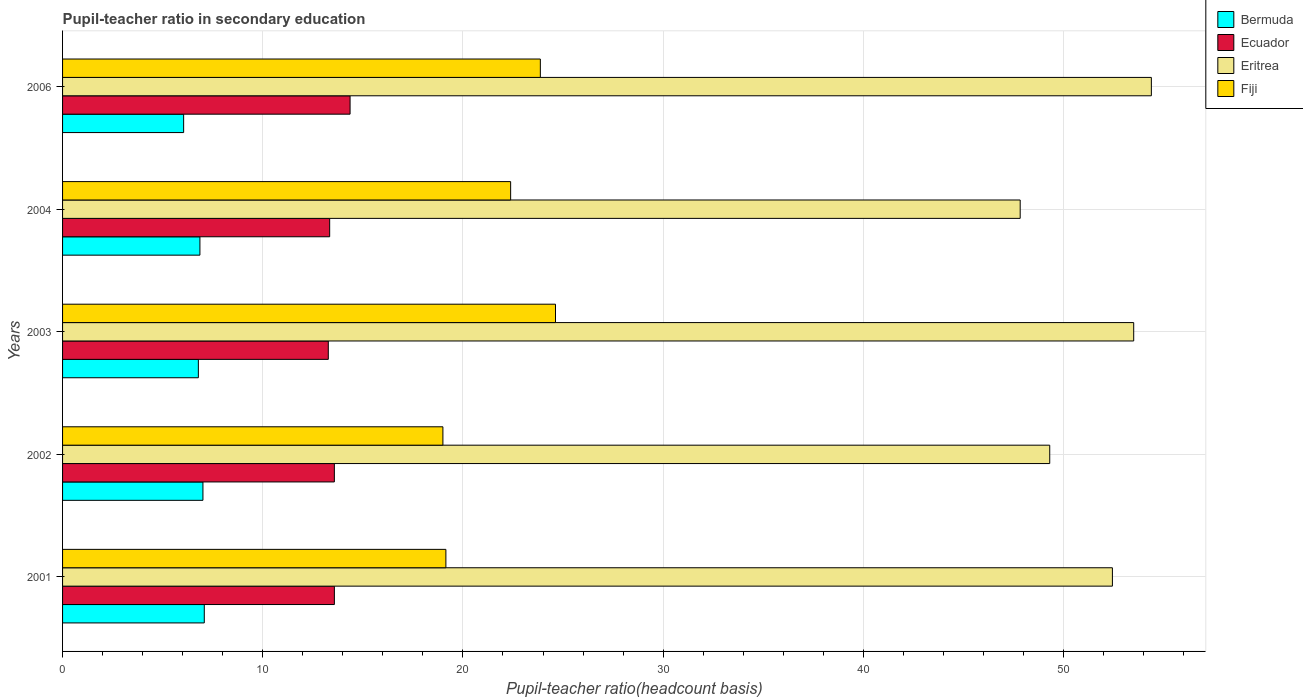How many groups of bars are there?
Your response must be concise. 5. How many bars are there on the 4th tick from the bottom?
Provide a succinct answer. 4. What is the label of the 3rd group of bars from the top?
Provide a succinct answer. 2003. What is the pupil-teacher ratio in secondary education in Ecuador in 2002?
Provide a short and direct response. 13.58. Across all years, what is the maximum pupil-teacher ratio in secondary education in Bermuda?
Provide a succinct answer. 7.08. Across all years, what is the minimum pupil-teacher ratio in secondary education in Fiji?
Give a very brief answer. 19. What is the total pupil-teacher ratio in secondary education in Bermuda in the graph?
Offer a terse response. 33.78. What is the difference between the pupil-teacher ratio in secondary education in Bermuda in 2002 and that in 2006?
Offer a very short reply. 0.96. What is the difference between the pupil-teacher ratio in secondary education in Ecuador in 2001 and the pupil-teacher ratio in secondary education in Bermuda in 2003?
Give a very brief answer. 6.8. What is the average pupil-teacher ratio in secondary education in Ecuador per year?
Make the answer very short. 13.63. In the year 2002, what is the difference between the pupil-teacher ratio in secondary education in Ecuador and pupil-teacher ratio in secondary education in Fiji?
Offer a terse response. -5.42. What is the ratio of the pupil-teacher ratio in secondary education in Ecuador in 2003 to that in 2006?
Give a very brief answer. 0.92. Is the pupil-teacher ratio in secondary education in Bermuda in 2001 less than that in 2003?
Provide a short and direct response. No. What is the difference between the highest and the second highest pupil-teacher ratio in secondary education in Fiji?
Your answer should be very brief. 0.76. What is the difference between the highest and the lowest pupil-teacher ratio in secondary education in Fiji?
Ensure brevity in your answer.  5.62. Is it the case that in every year, the sum of the pupil-teacher ratio in secondary education in Ecuador and pupil-teacher ratio in secondary education in Eritrea is greater than the sum of pupil-teacher ratio in secondary education in Fiji and pupil-teacher ratio in secondary education in Bermuda?
Your response must be concise. Yes. What does the 4th bar from the top in 2003 represents?
Offer a terse response. Bermuda. What does the 3rd bar from the bottom in 2004 represents?
Provide a short and direct response. Eritrea. Is it the case that in every year, the sum of the pupil-teacher ratio in secondary education in Ecuador and pupil-teacher ratio in secondary education in Eritrea is greater than the pupil-teacher ratio in secondary education in Bermuda?
Keep it short and to the point. Yes. Are all the bars in the graph horizontal?
Make the answer very short. Yes. Are the values on the major ticks of X-axis written in scientific E-notation?
Provide a succinct answer. No. Does the graph contain any zero values?
Provide a succinct answer. No. Does the graph contain grids?
Give a very brief answer. Yes. How many legend labels are there?
Give a very brief answer. 4. What is the title of the graph?
Your response must be concise. Pupil-teacher ratio in secondary education. What is the label or title of the X-axis?
Your answer should be compact. Pupil-teacher ratio(headcount basis). What is the Pupil-teacher ratio(headcount basis) in Bermuda in 2001?
Give a very brief answer. 7.08. What is the Pupil-teacher ratio(headcount basis) in Ecuador in 2001?
Give a very brief answer. 13.58. What is the Pupil-teacher ratio(headcount basis) in Eritrea in 2001?
Provide a short and direct response. 52.44. What is the Pupil-teacher ratio(headcount basis) of Fiji in 2001?
Your answer should be compact. 19.15. What is the Pupil-teacher ratio(headcount basis) in Bermuda in 2002?
Ensure brevity in your answer.  7.01. What is the Pupil-teacher ratio(headcount basis) of Ecuador in 2002?
Your response must be concise. 13.58. What is the Pupil-teacher ratio(headcount basis) in Eritrea in 2002?
Provide a succinct answer. 49.31. What is the Pupil-teacher ratio(headcount basis) in Fiji in 2002?
Make the answer very short. 19. What is the Pupil-teacher ratio(headcount basis) in Bermuda in 2003?
Offer a terse response. 6.78. What is the Pupil-teacher ratio(headcount basis) of Ecuador in 2003?
Provide a succinct answer. 13.27. What is the Pupil-teacher ratio(headcount basis) of Eritrea in 2003?
Provide a succinct answer. 53.51. What is the Pupil-teacher ratio(headcount basis) of Fiji in 2003?
Provide a succinct answer. 24.62. What is the Pupil-teacher ratio(headcount basis) of Bermuda in 2004?
Your response must be concise. 6.86. What is the Pupil-teacher ratio(headcount basis) of Ecuador in 2004?
Your response must be concise. 13.34. What is the Pupil-teacher ratio(headcount basis) in Eritrea in 2004?
Your response must be concise. 47.84. What is the Pupil-teacher ratio(headcount basis) of Fiji in 2004?
Your answer should be compact. 22.38. What is the Pupil-teacher ratio(headcount basis) of Bermuda in 2006?
Your answer should be compact. 6.05. What is the Pupil-teacher ratio(headcount basis) in Ecuador in 2006?
Your answer should be compact. 14.36. What is the Pupil-teacher ratio(headcount basis) in Eritrea in 2006?
Ensure brevity in your answer.  54.39. What is the Pupil-teacher ratio(headcount basis) in Fiji in 2006?
Ensure brevity in your answer.  23.87. Across all years, what is the maximum Pupil-teacher ratio(headcount basis) in Bermuda?
Ensure brevity in your answer.  7.08. Across all years, what is the maximum Pupil-teacher ratio(headcount basis) in Ecuador?
Your answer should be compact. 14.36. Across all years, what is the maximum Pupil-teacher ratio(headcount basis) in Eritrea?
Provide a succinct answer. 54.39. Across all years, what is the maximum Pupil-teacher ratio(headcount basis) in Fiji?
Ensure brevity in your answer.  24.62. Across all years, what is the minimum Pupil-teacher ratio(headcount basis) in Bermuda?
Offer a terse response. 6.05. Across all years, what is the minimum Pupil-teacher ratio(headcount basis) of Ecuador?
Give a very brief answer. 13.27. Across all years, what is the minimum Pupil-teacher ratio(headcount basis) in Eritrea?
Provide a succinct answer. 47.84. Across all years, what is the minimum Pupil-teacher ratio(headcount basis) of Fiji?
Keep it short and to the point. 19. What is the total Pupil-teacher ratio(headcount basis) of Bermuda in the graph?
Your response must be concise. 33.78. What is the total Pupil-teacher ratio(headcount basis) of Ecuador in the graph?
Ensure brevity in your answer.  68.14. What is the total Pupil-teacher ratio(headcount basis) in Eritrea in the graph?
Offer a terse response. 257.49. What is the total Pupil-teacher ratio(headcount basis) of Fiji in the graph?
Offer a very short reply. 109.02. What is the difference between the Pupil-teacher ratio(headcount basis) of Bermuda in 2001 and that in 2002?
Ensure brevity in your answer.  0.07. What is the difference between the Pupil-teacher ratio(headcount basis) in Ecuador in 2001 and that in 2002?
Ensure brevity in your answer.  0. What is the difference between the Pupil-teacher ratio(headcount basis) in Eritrea in 2001 and that in 2002?
Your answer should be compact. 3.13. What is the difference between the Pupil-teacher ratio(headcount basis) in Fiji in 2001 and that in 2002?
Give a very brief answer. 0.15. What is the difference between the Pupil-teacher ratio(headcount basis) in Bermuda in 2001 and that in 2003?
Offer a very short reply. 0.3. What is the difference between the Pupil-teacher ratio(headcount basis) in Ecuador in 2001 and that in 2003?
Your answer should be compact. 0.3. What is the difference between the Pupil-teacher ratio(headcount basis) of Eritrea in 2001 and that in 2003?
Make the answer very short. -1.06. What is the difference between the Pupil-teacher ratio(headcount basis) of Fiji in 2001 and that in 2003?
Your answer should be compact. -5.48. What is the difference between the Pupil-teacher ratio(headcount basis) of Bermuda in 2001 and that in 2004?
Keep it short and to the point. 0.22. What is the difference between the Pupil-teacher ratio(headcount basis) in Ecuador in 2001 and that in 2004?
Ensure brevity in your answer.  0.24. What is the difference between the Pupil-teacher ratio(headcount basis) of Eritrea in 2001 and that in 2004?
Offer a very short reply. 4.61. What is the difference between the Pupil-teacher ratio(headcount basis) in Fiji in 2001 and that in 2004?
Keep it short and to the point. -3.23. What is the difference between the Pupil-teacher ratio(headcount basis) of Bermuda in 2001 and that in 2006?
Your response must be concise. 1.03. What is the difference between the Pupil-teacher ratio(headcount basis) of Ecuador in 2001 and that in 2006?
Ensure brevity in your answer.  -0.78. What is the difference between the Pupil-teacher ratio(headcount basis) in Eritrea in 2001 and that in 2006?
Your answer should be compact. -1.95. What is the difference between the Pupil-teacher ratio(headcount basis) in Fiji in 2001 and that in 2006?
Provide a succinct answer. -4.72. What is the difference between the Pupil-teacher ratio(headcount basis) of Bermuda in 2002 and that in 2003?
Offer a terse response. 0.23. What is the difference between the Pupil-teacher ratio(headcount basis) of Ecuador in 2002 and that in 2003?
Offer a terse response. 0.3. What is the difference between the Pupil-teacher ratio(headcount basis) in Eritrea in 2002 and that in 2003?
Your answer should be compact. -4.19. What is the difference between the Pupil-teacher ratio(headcount basis) in Fiji in 2002 and that in 2003?
Your response must be concise. -5.62. What is the difference between the Pupil-teacher ratio(headcount basis) in Bermuda in 2002 and that in 2004?
Give a very brief answer. 0.15. What is the difference between the Pupil-teacher ratio(headcount basis) of Ecuador in 2002 and that in 2004?
Your answer should be compact. 0.23. What is the difference between the Pupil-teacher ratio(headcount basis) of Eritrea in 2002 and that in 2004?
Make the answer very short. 1.48. What is the difference between the Pupil-teacher ratio(headcount basis) in Fiji in 2002 and that in 2004?
Keep it short and to the point. -3.38. What is the difference between the Pupil-teacher ratio(headcount basis) in Bermuda in 2002 and that in 2006?
Offer a terse response. 0.96. What is the difference between the Pupil-teacher ratio(headcount basis) in Ecuador in 2002 and that in 2006?
Offer a terse response. -0.78. What is the difference between the Pupil-teacher ratio(headcount basis) in Eritrea in 2002 and that in 2006?
Provide a succinct answer. -5.08. What is the difference between the Pupil-teacher ratio(headcount basis) of Fiji in 2002 and that in 2006?
Your answer should be compact. -4.87. What is the difference between the Pupil-teacher ratio(headcount basis) of Bermuda in 2003 and that in 2004?
Provide a succinct answer. -0.08. What is the difference between the Pupil-teacher ratio(headcount basis) of Ecuador in 2003 and that in 2004?
Your answer should be compact. -0.07. What is the difference between the Pupil-teacher ratio(headcount basis) in Eritrea in 2003 and that in 2004?
Keep it short and to the point. 5.67. What is the difference between the Pupil-teacher ratio(headcount basis) in Fiji in 2003 and that in 2004?
Provide a short and direct response. 2.24. What is the difference between the Pupil-teacher ratio(headcount basis) in Bermuda in 2003 and that in 2006?
Give a very brief answer. 0.73. What is the difference between the Pupil-teacher ratio(headcount basis) of Ecuador in 2003 and that in 2006?
Your answer should be very brief. -1.09. What is the difference between the Pupil-teacher ratio(headcount basis) of Eritrea in 2003 and that in 2006?
Your response must be concise. -0.88. What is the difference between the Pupil-teacher ratio(headcount basis) of Fiji in 2003 and that in 2006?
Ensure brevity in your answer.  0.76. What is the difference between the Pupil-teacher ratio(headcount basis) in Bermuda in 2004 and that in 2006?
Offer a terse response. 0.81. What is the difference between the Pupil-teacher ratio(headcount basis) in Ecuador in 2004 and that in 2006?
Ensure brevity in your answer.  -1.02. What is the difference between the Pupil-teacher ratio(headcount basis) of Eritrea in 2004 and that in 2006?
Make the answer very short. -6.55. What is the difference between the Pupil-teacher ratio(headcount basis) of Fiji in 2004 and that in 2006?
Provide a short and direct response. -1.48. What is the difference between the Pupil-teacher ratio(headcount basis) in Bermuda in 2001 and the Pupil-teacher ratio(headcount basis) in Ecuador in 2002?
Provide a succinct answer. -6.5. What is the difference between the Pupil-teacher ratio(headcount basis) of Bermuda in 2001 and the Pupil-teacher ratio(headcount basis) of Eritrea in 2002?
Ensure brevity in your answer.  -42.23. What is the difference between the Pupil-teacher ratio(headcount basis) in Bermuda in 2001 and the Pupil-teacher ratio(headcount basis) in Fiji in 2002?
Your answer should be compact. -11.92. What is the difference between the Pupil-teacher ratio(headcount basis) in Ecuador in 2001 and the Pupil-teacher ratio(headcount basis) in Eritrea in 2002?
Offer a terse response. -35.73. What is the difference between the Pupil-teacher ratio(headcount basis) in Ecuador in 2001 and the Pupil-teacher ratio(headcount basis) in Fiji in 2002?
Offer a very short reply. -5.42. What is the difference between the Pupil-teacher ratio(headcount basis) of Eritrea in 2001 and the Pupil-teacher ratio(headcount basis) of Fiji in 2002?
Make the answer very short. 33.44. What is the difference between the Pupil-teacher ratio(headcount basis) of Bermuda in 2001 and the Pupil-teacher ratio(headcount basis) of Ecuador in 2003?
Your answer should be compact. -6.2. What is the difference between the Pupil-teacher ratio(headcount basis) of Bermuda in 2001 and the Pupil-teacher ratio(headcount basis) of Eritrea in 2003?
Your answer should be compact. -46.43. What is the difference between the Pupil-teacher ratio(headcount basis) in Bermuda in 2001 and the Pupil-teacher ratio(headcount basis) in Fiji in 2003?
Offer a very short reply. -17.54. What is the difference between the Pupil-teacher ratio(headcount basis) of Ecuador in 2001 and the Pupil-teacher ratio(headcount basis) of Eritrea in 2003?
Offer a very short reply. -39.93. What is the difference between the Pupil-teacher ratio(headcount basis) in Ecuador in 2001 and the Pupil-teacher ratio(headcount basis) in Fiji in 2003?
Provide a succinct answer. -11.05. What is the difference between the Pupil-teacher ratio(headcount basis) in Eritrea in 2001 and the Pupil-teacher ratio(headcount basis) in Fiji in 2003?
Make the answer very short. 27.82. What is the difference between the Pupil-teacher ratio(headcount basis) of Bermuda in 2001 and the Pupil-teacher ratio(headcount basis) of Ecuador in 2004?
Offer a terse response. -6.26. What is the difference between the Pupil-teacher ratio(headcount basis) in Bermuda in 2001 and the Pupil-teacher ratio(headcount basis) in Eritrea in 2004?
Your answer should be compact. -40.76. What is the difference between the Pupil-teacher ratio(headcount basis) in Bermuda in 2001 and the Pupil-teacher ratio(headcount basis) in Fiji in 2004?
Keep it short and to the point. -15.3. What is the difference between the Pupil-teacher ratio(headcount basis) of Ecuador in 2001 and the Pupil-teacher ratio(headcount basis) of Eritrea in 2004?
Give a very brief answer. -34.26. What is the difference between the Pupil-teacher ratio(headcount basis) of Ecuador in 2001 and the Pupil-teacher ratio(headcount basis) of Fiji in 2004?
Offer a terse response. -8.8. What is the difference between the Pupil-teacher ratio(headcount basis) in Eritrea in 2001 and the Pupil-teacher ratio(headcount basis) in Fiji in 2004?
Your response must be concise. 30.06. What is the difference between the Pupil-teacher ratio(headcount basis) of Bermuda in 2001 and the Pupil-teacher ratio(headcount basis) of Ecuador in 2006?
Your answer should be compact. -7.28. What is the difference between the Pupil-teacher ratio(headcount basis) in Bermuda in 2001 and the Pupil-teacher ratio(headcount basis) in Eritrea in 2006?
Your response must be concise. -47.31. What is the difference between the Pupil-teacher ratio(headcount basis) in Bermuda in 2001 and the Pupil-teacher ratio(headcount basis) in Fiji in 2006?
Make the answer very short. -16.79. What is the difference between the Pupil-teacher ratio(headcount basis) of Ecuador in 2001 and the Pupil-teacher ratio(headcount basis) of Eritrea in 2006?
Provide a short and direct response. -40.81. What is the difference between the Pupil-teacher ratio(headcount basis) of Ecuador in 2001 and the Pupil-teacher ratio(headcount basis) of Fiji in 2006?
Offer a terse response. -10.29. What is the difference between the Pupil-teacher ratio(headcount basis) in Eritrea in 2001 and the Pupil-teacher ratio(headcount basis) in Fiji in 2006?
Keep it short and to the point. 28.58. What is the difference between the Pupil-teacher ratio(headcount basis) in Bermuda in 2002 and the Pupil-teacher ratio(headcount basis) in Ecuador in 2003?
Offer a very short reply. -6.26. What is the difference between the Pupil-teacher ratio(headcount basis) of Bermuda in 2002 and the Pupil-teacher ratio(headcount basis) of Eritrea in 2003?
Your answer should be compact. -46.5. What is the difference between the Pupil-teacher ratio(headcount basis) of Bermuda in 2002 and the Pupil-teacher ratio(headcount basis) of Fiji in 2003?
Your response must be concise. -17.61. What is the difference between the Pupil-teacher ratio(headcount basis) of Ecuador in 2002 and the Pupil-teacher ratio(headcount basis) of Eritrea in 2003?
Provide a short and direct response. -39.93. What is the difference between the Pupil-teacher ratio(headcount basis) in Ecuador in 2002 and the Pupil-teacher ratio(headcount basis) in Fiji in 2003?
Provide a short and direct response. -11.05. What is the difference between the Pupil-teacher ratio(headcount basis) in Eritrea in 2002 and the Pupil-teacher ratio(headcount basis) in Fiji in 2003?
Your response must be concise. 24.69. What is the difference between the Pupil-teacher ratio(headcount basis) in Bermuda in 2002 and the Pupil-teacher ratio(headcount basis) in Ecuador in 2004?
Give a very brief answer. -6.33. What is the difference between the Pupil-teacher ratio(headcount basis) in Bermuda in 2002 and the Pupil-teacher ratio(headcount basis) in Eritrea in 2004?
Offer a terse response. -40.83. What is the difference between the Pupil-teacher ratio(headcount basis) of Bermuda in 2002 and the Pupil-teacher ratio(headcount basis) of Fiji in 2004?
Provide a succinct answer. -15.37. What is the difference between the Pupil-teacher ratio(headcount basis) of Ecuador in 2002 and the Pupil-teacher ratio(headcount basis) of Eritrea in 2004?
Provide a succinct answer. -34.26. What is the difference between the Pupil-teacher ratio(headcount basis) of Ecuador in 2002 and the Pupil-teacher ratio(headcount basis) of Fiji in 2004?
Provide a short and direct response. -8.81. What is the difference between the Pupil-teacher ratio(headcount basis) of Eritrea in 2002 and the Pupil-teacher ratio(headcount basis) of Fiji in 2004?
Give a very brief answer. 26.93. What is the difference between the Pupil-teacher ratio(headcount basis) of Bermuda in 2002 and the Pupil-teacher ratio(headcount basis) of Ecuador in 2006?
Ensure brevity in your answer.  -7.35. What is the difference between the Pupil-teacher ratio(headcount basis) of Bermuda in 2002 and the Pupil-teacher ratio(headcount basis) of Eritrea in 2006?
Keep it short and to the point. -47.38. What is the difference between the Pupil-teacher ratio(headcount basis) in Bermuda in 2002 and the Pupil-teacher ratio(headcount basis) in Fiji in 2006?
Ensure brevity in your answer.  -16.86. What is the difference between the Pupil-teacher ratio(headcount basis) in Ecuador in 2002 and the Pupil-teacher ratio(headcount basis) in Eritrea in 2006?
Your response must be concise. -40.81. What is the difference between the Pupil-teacher ratio(headcount basis) of Ecuador in 2002 and the Pupil-teacher ratio(headcount basis) of Fiji in 2006?
Make the answer very short. -10.29. What is the difference between the Pupil-teacher ratio(headcount basis) in Eritrea in 2002 and the Pupil-teacher ratio(headcount basis) in Fiji in 2006?
Keep it short and to the point. 25.45. What is the difference between the Pupil-teacher ratio(headcount basis) in Bermuda in 2003 and the Pupil-teacher ratio(headcount basis) in Ecuador in 2004?
Ensure brevity in your answer.  -6.56. What is the difference between the Pupil-teacher ratio(headcount basis) of Bermuda in 2003 and the Pupil-teacher ratio(headcount basis) of Eritrea in 2004?
Ensure brevity in your answer.  -41.05. What is the difference between the Pupil-teacher ratio(headcount basis) in Bermuda in 2003 and the Pupil-teacher ratio(headcount basis) in Fiji in 2004?
Give a very brief answer. -15.6. What is the difference between the Pupil-teacher ratio(headcount basis) in Ecuador in 2003 and the Pupil-teacher ratio(headcount basis) in Eritrea in 2004?
Your answer should be very brief. -34.56. What is the difference between the Pupil-teacher ratio(headcount basis) of Ecuador in 2003 and the Pupil-teacher ratio(headcount basis) of Fiji in 2004?
Your answer should be compact. -9.11. What is the difference between the Pupil-teacher ratio(headcount basis) in Eritrea in 2003 and the Pupil-teacher ratio(headcount basis) in Fiji in 2004?
Offer a terse response. 31.12. What is the difference between the Pupil-teacher ratio(headcount basis) of Bermuda in 2003 and the Pupil-teacher ratio(headcount basis) of Ecuador in 2006?
Keep it short and to the point. -7.58. What is the difference between the Pupil-teacher ratio(headcount basis) of Bermuda in 2003 and the Pupil-teacher ratio(headcount basis) of Eritrea in 2006?
Your answer should be compact. -47.61. What is the difference between the Pupil-teacher ratio(headcount basis) in Bermuda in 2003 and the Pupil-teacher ratio(headcount basis) in Fiji in 2006?
Your response must be concise. -17.08. What is the difference between the Pupil-teacher ratio(headcount basis) of Ecuador in 2003 and the Pupil-teacher ratio(headcount basis) of Eritrea in 2006?
Provide a short and direct response. -41.12. What is the difference between the Pupil-teacher ratio(headcount basis) of Ecuador in 2003 and the Pupil-teacher ratio(headcount basis) of Fiji in 2006?
Make the answer very short. -10.59. What is the difference between the Pupil-teacher ratio(headcount basis) in Eritrea in 2003 and the Pupil-teacher ratio(headcount basis) in Fiji in 2006?
Ensure brevity in your answer.  29.64. What is the difference between the Pupil-teacher ratio(headcount basis) in Bermuda in 2004 and the Pupil-teacher ratio(headcount basis) in Ecuador in 2006?
Your response must be concise. -7.5. What is the difference between the Pupil-teacher ratio(headcount basis) of Bermuda in 2004 and the Pupil-teacher ratio(headcount basis) of Eritrea in 2006?
Give a very brief answer. -47.53. What is the difference between the Pupil-teacher ratio(headcount basis) of Bermuda in 2004 and the Pupil-teacher ratio(headcount basis) of Fiji in 2006?
Your response must be concise. -17.01. What is the difference between the Pupil-teacher ratio(headcount basis) in Ecuador in 2004 and the Pupil-teacher ratio(headcount basis) in Eritrea in 2006?
Make the answer very short. -41.05. What is the difference between the Pupil-teacher ratio(headcount basis) in Ecuador in 2004 and the Pupil-teacher ratio(headcount basis) in Fiji in 2006?
Give a very brief answer. -10.52. What is the difference between the Pupil-teacher ratio(headcount basis) of Eritrea in 2004 and the Pupil-teacher ratio(headcount basis) of Fiji in 2006?
Your answer should be very brief. 23.97. What is the average Pupil-teacher ratio(headcount basis) of Bermuda per year?
Your answer should be compact. 6.76. What is the average Pupil-teacher ratio(headcount basis) in Ecuador per year?
Your answer should be compact. 13.63. What is the average Pupil-teacher ratio(headcount basis) in Eritrea per year?
Offer a very short reply. 51.5. What is the average Pupil-teacher ratio(headcount basis) of Fiji per year?
Offer a terse response. 21.8. In the year 2001, what is the difference between the Pupil-teacher ratio(headcount basis) in Bermuda and Pupil-teacher ratio(headcount basis) in Ecuador?
Provide a short and direct response. -6.5. In the year 2001, what is the difference between the Pupil-teacher ratio(headcount basis) of Bermuda and Pupil-teacher ratio(headcount basis) of Eritrea?
Ensure brevity in your answer.  -45.37. In the year 2001, what is the difference between the Pupil-teacher ratio(headcount basis) of Bermuda and Pupil-teacher ratio(headcount basis) of Fiji?
Make the answer very short. -12.07. In the year 2001, what is the difference between the Pupil-teacher ratio(headcount basis) in Ecuador and Pupil-teacher ratio(headcount basis) in Eritrea?
Make the answer very short. -38.87. In the year 2001, what is the difference between the Pupil-teacher ratio(headcount basis) in Ecuador and Pupil-teacher ratio(headcount basis) in Fiji?
Your answer should be compact. -5.57. In the year 2001, what is the difference between the Pupil-teacher ratio(headcount basis) of Eritrea and Pupil-teacher ratio(headcount basis) of Fiji?
Provide a short and direct response. 33.3. In the year 2002, what is the difference between the Pupil-teacher ratio(headcount basis) in Bermuda and Pupil-teacher ratio(headcount basis) in Ecuador?
Offer a terse response. -6.57. In the year 2002, what is the difference between the Pupil-teacher ratio(headcount basis) in Bermuda and Pupil-teacher ratio(headcount basis) in Eritrea?
Offer a terse response. -42.3. In the year 2002, what is the difference between the Pupil-teacher ratio(headcount basis) of Bermuda and Pupil-teacher ratio(headcount basis) of Fiji?
Make the answer very short. -11.99. In the year 2002, what is the difference between the Pupil-teacher ratio(headcount basis) of Ecuador and Pupil-teacher ratio(headcount basis) of Eritrea?
Your answer should be very brief. -35.74. In the year 2002, what is the difference between the Pupil-teacher ratio(headcount basis) of Ecuador and Pupil-teacher ratio(headcount basis) of Fiji?
Offer a terse response. -5.42. In the year 2002, what is the difference between the Pupil-teacher ratio(headcount basis) of Eritrea and Pupil-teacher ratio(headcount basis) of Fiji?
Your answer should be very brief. 30.31. In the year 2003, what is the difference between the Pupil-teacher ratio(headcount basis) in Bermuda and Pupil-teacher ratio(headcount basis) in Ecuador?
Keep it short and to the point. -6.49. In the year 2003, what is the difference between the Pupil-teacher ratio(headcount basis) in Bermuda and Pupil-teacher ratio(headcount basis) in Eritrea?
Keep it short and to the point. -46.72. In the year 2003, what is the difference between the Pupil-teacher ratio(headcount basis) in Bermuda and Pupil-teacher ratio(headcount basis) in Fiji?
Your answer should be very brief. -17.84. In the year 2003, what is the difference between the Pupil-teacher ratio(headcount basis) of Ecuador and Pupil-teacher ratio(headcount basis) of Eritrea?
Your response must be concise. -40.23. In the year 2003, what is the difference between the Pupil-teacher ratio(headcount basis) of Ecuador and Pupil-teacher ratio(headcount basis) of Fiji?
Your answer should be compact. -11.35. In the year 2003, what is the difference between the Pupil-teacher ratio(headcount basis) of Eritrea and Pupil-teacher ratio(headcount basis) of Fiji?
Your response must be concise. 28.88. In the year 2004, what is the difference between the Pupil-teacher ratio(headcount basis) in Bermuda and Pupil-teacher ratio(headcount basis) in Ecuador?
Offer a terse response. -6.48. In the year 2004, what is the difference between the Pupil-teacher ratio(headcount basis) of Bermuda and Pupil-teacher ratio(headcount basis) of Eritrea?
Offer a terse response. -40.98. In the year 2004, what is the difference between the Pupil-teacher ratio(headcount basis) of Bermuda and Pupil-teacher ratio(headcount basis) of Fiji?
Make the answer very short. -15.52. In the year 2004, what is the difference between the Pupil-teacher ratio(headcount basis) in Ecuador and Pupil-teacher ratio(headcount basis) in Eritrea?
Keep it short and to the point. -34.49. In the year 2004, what is the difference between the Pupil-teacher ratio(headcount basis) in Ecuador and Pupil-teacher ratio(headcount basis) in Fiji?
Offer a terse response. -9.04. In the year 2004, what is the difference between the Pupil-teacher ratio(headcount basis) of Eritrea and Pupil-teacher ratio(headcount basis) of Fiji?
Make the answer very short. 25.45. In the year 2006, what is the difference between the Pupil-teacher ratio(headcount basis) of Bermuda and Pupil-teacher ratio(headcount basis) of Ecuador?
Give a very brief answer. -8.31. In the year 2006, what is the difference between the Pupil-teacher ratio(headcount basis) of Bermuda and Pupil-teacher ratio(headcount basis) of Eritrea?
Offer a very short reply. -48.34. In the year 2006, what is the difference between the Pupil-teacher ratio(headcount basis) of Bermuda and Pupil-teacher ratio(headcount basis) of Fiji?
Offer a very short reply. -17.82. In the year 2006, what is the difference between the Pupil-teacher ratio(headcount basis) of Ecuador and Pupil-teacher ratio(headcount basis) of Eritrea?
Make the answer very short. -40.03. In the year 2006, what is the difference between the Pupil-teacher ratio(headcount basis) of Ecuador and Pupil-teacher ratio(headcount basis) of Fiji?
Your answer should be compact. -9.51. In the year 2006, what is the difference between the Pupil-teacher ratio(headcount basis) in Eritrea and Pupil-teacher ratio(headcount basis) in Fiji?
Provide a short and direct response. 30.52. What is the ratio of the Pupil-teacher ratio(headcount basis) of Bermuda in 2001 to that in 2002?
Give a very brief answer. 1.01. What is the ratio of the Pupil-teacher ratio(headcount basis) of Ecuador in 2001 to that in 2002?
Keep it short and to the point. 1. What is the ratio of the Pupil-teacher ratio(headcount basis) of Eritrea in 2001 to that in 2002?
Provide a short and direct response. 1.06. What is the ratio of the Pupil-teacher ratio(headcount basis) of Bermuda in 2001 to that in 2003?
Your response must be concise. 1.04. What is the ratio of the Pupil-teacher ratio(headcount basis) of Ecuador in 2001 to that in 2003?
Offer a very short reply. 1.02. What is the ratio of the Pupil-teacher ratio(headcount basis) of Eritrea in 2001 to that in 2003?
Your response must be concise. 0.98. What is the ratio of the Pupil-teacher ratio(headcount basis) in Fiji in 2001 to that in 2003?
Provide a short and direct response. 0.78. What is the ratio of the Pupil-teacher ratio(headcount basis) of Bermuda in 2001 to that in 2004?
Keep it short and to the point. 1.03. What is the ratio of the Pupil-teacher ratio(headcount basis) in Ecuador in 2001 to that in 2004?
Keep it short and to the point. 1.02. What is the ratio of the Pupil-teacher ratio(headcount basis) in Eritrea in 2001 to that in 2004?
Keep it short and to the point. 1.1. What is the ratio of the Pupil-teacher ratio(headcount basis) of Fiji in 2001 to that in 2004?
Keep it short and to the point. 0.86. What is the ratio of the Pupil-teacher ratio(headcount basis) in Bermuda in 2001 to that in 2006?
Your answer should be compact. 1.17. What is the ratio of the Pupil-teacher ratio(headcount basis) in Ecuador in 2001 to that in 2006?
Provide a short and direct response. 0.95. What is the ratio of the Pupil-teacher ratio(headcount basis) of Eritrea in 2001 to that in 2006?
Provide a succinct answer. 0.96. What is the ratio of the Pupil-teacher ratio(headcount basis) in Fiji in 2001 to that in 2006?
Give a very brief answer. 0.8. What is the ratio of the Pupil-teacher ratio(headcount basis) of Bermuda in 2002 to that in 2003?
Offer a terse response. 1.03. What is the ratio of the Pupil-teacher ratio(headcount basis) in Ecuador in 2002 to that in 2003?
Ensure brevity in your answer.  1.02. What is the ratio of the Pupil-teacher ratio(headcount basis) in Eritrea in 2002 to that in 2003?
Offer a very short reply. 0.92. What is the ratio of the Pupil-teacher ratio(headcount basis) in Fiji in 2002 to that in 2003?
Ensure brevity in your answer.  0.77. What is the ratio of the Pupil-teacher ratio(headcount basis) in Bermuda in 2002 to that in 2004?
Make the answer very short. 1.02. What is the ratio of the Pupil-teacher ratio(headcount basis) of Ecuador in 2002 to that in 2004?
Your answer should be compact. 1.02. What is the ratio of the Pupil-teacher ratio(headcount basis) of Eritrea in 2002 to that in 2004?
Ensure brevity in your answer.  1.03. What is the ratio of the Pupil-teacher ratio(headcount basis) in Fiji in 2002 to that in 2004?
Provide a short and direct response. 0.85. What is the ratio of the Pupil-teacher ratio(headcount basis) in Bermuda in 2002 to that in 2006?
Your answer should be compact. 1.16. What is the ratio of the Pupil-teacher ratio(headcount basis) of Ecuador in 2002 to that in 2006?
Provide a short and direct response. 0.95. What is the ratio of the Pupil-teacher ratio(headcount basis) in Eritrea in 2002 to that in 2006?
Provide a short and direct response. 0.91. What is the ratio of the Pupil-teacher ratio(headcount basis) in Fiji in 2002 to that in 2006?
Your answer should be compact. 0.8. What is the ratio of the Pupil-teacher ratio(headcount basis) of Ecuador in 2003 to that in 2004?
Your response must be concise. 0.99. What is the ratio of the Pupil-teacher ratio(headcount basis) of Eritrea in 2003 to that in 2004?
Ensure brevity in your answer.  1.12. What is the ratio of the Pupil-teacher ratio(headcount basis) in Fiji in 2003 to that in 2004?
Your answer should be very brief. 1.1. What is the ratio of the Pupil-teacher ratio(headcount basis) of Bermuda in 2003 to that in 2006?
Ensure brevity in your answer.  1.12. What is the ratio of the Pupil-teacher ratio(headcount basis) in Ecuador in 2003 to that in 2006?
Ensure brevity in your answer.  0.92. What is the ratio of the Pupil-teacher ratio(headcount basis) in Eritrea in 2003 to that in 2006?
Offer a very short reply. 0.98. What is the ratio of the Pupil-teacher ratio(headcount basis) in Fiji in 2003 to that in 2006?
Provide a succinct answer. 1.03. What is the ratio of the Pupil-teacher ratio(headcount basis) in Bermuda in 2004 to that in 2006?
Provide a succinct answer. 1.13. What is the ratio of the Pupil-teacher ratio(headcount basis) of Ecuador in 2004 to that in 2006?
Your answer should be very brief. 0.93. What is the ratio of the Pupil-teacher ratio(headcount basis) of Eritrea in 2004 to that in 2006?
Your answer should be very brief. 0.88. What is the ratio of the Pupil-teacher ratio(headcount basis) of Fiji in 2004 to that in 2006?
Your answer should be very brief. 0.94. What is the difference between the highest and the second highest Pupil-teacher ratio(headcount basis) in Bermuda?
Make the answer very short. 0.07. What is the difference between the highest and the second highest Pupil-teacher ratio(headcount basis) in Ecuador?
Your answer should be very brief. 0.78. What is the difference between the highest and the second highest Pupil-teacher ratio(headcount basis) in Eritrea?
Your answer should be compact. 0.88. What is the difference between the highest and the second highest Pupil-teacher ratio(headcount basis) of Fiji?
Provide a succinct answer. 0.76. What is the difference between the highest and the lowest Pupil-teacher ratio(headcount basis) of Bermuda?
Give a very brief answer. 1.03. What is the difference between the highest and the lowest Pupil-teacher ratio(headcount basis) in Ecuador?
Provide a succinct answer. 1.09. What is the difference between the highest and the lowest Pupil-teacher ratio(headcount basis) of Eritrea?
Keep it short and to the point. 6.55. What is the difference between the highest and the lowest Pupil-teacher ratio(headcount basis) in Fiji?
Offer a terse response. 5.62. 